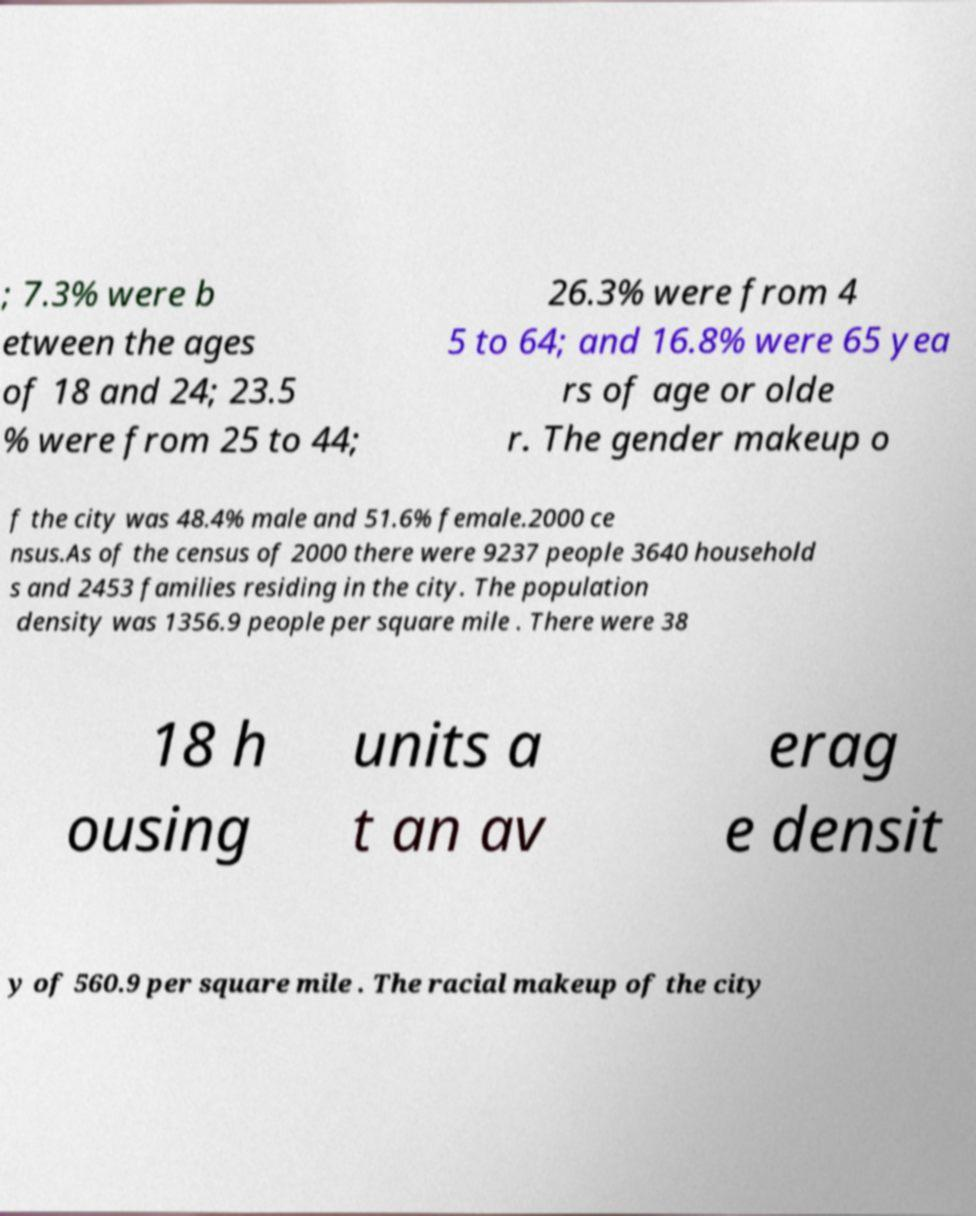Can you accurately transcribe the text from the provided image for me? ; 7.3% were b etween the ages of 18 and 24; 23.5 % were from 25 to 44; 26.3% were from 4 5 to 64; and 16.8% were 65 yea rs of age or olde r. The gender makeup o f the city was 48.4% male and 51.6% female.2000 ce nsus.As of the census of 2000 there were 9237 people 3640 household s and 2453 families residing in the city. The population density was 1356.9 people per square mile . There were 38 18 h ousing units a t an av erag e densit y of 560.9 per square mile . The racial makeup of the city 